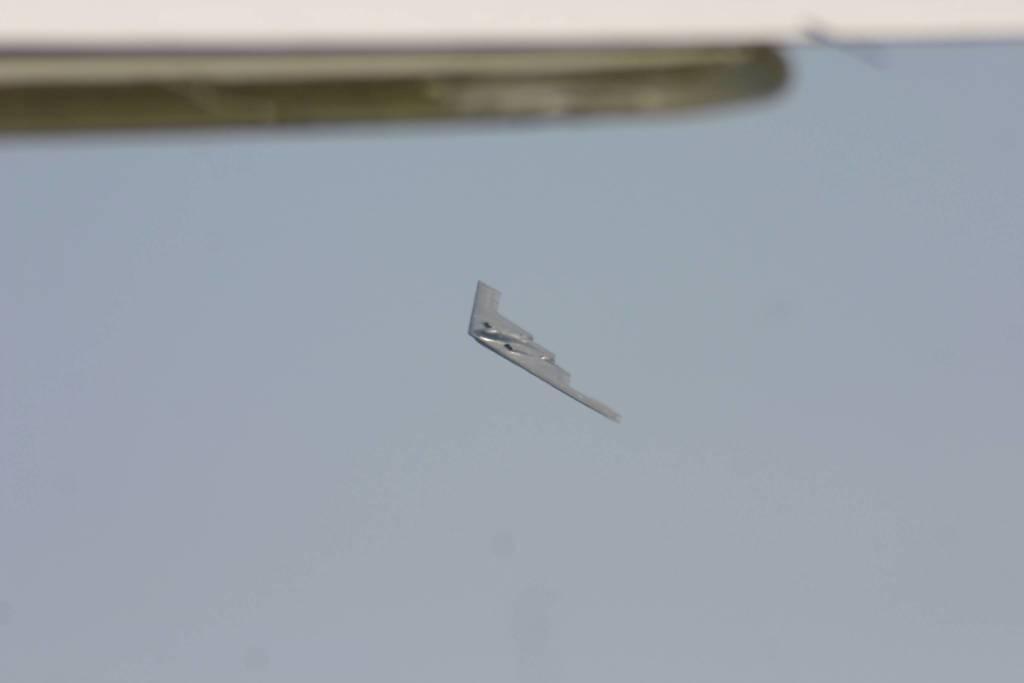Please provide a concise description of this image. In the middle of this image, there is an aircraft flying in the air. At the top of this image, there is an object. In the background, there are clouds in the blue sky. 